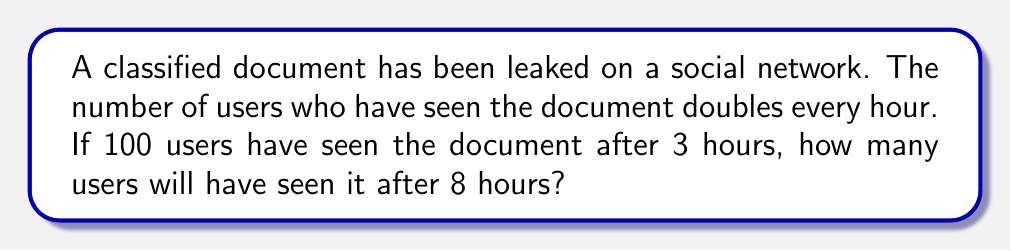Solve this math problem. Let's approach this step-by-step:

1) First, we need to find the initial number of users who saw the document.
   Let $x$ be the initial number of users.

2) After 3 hours, the number of users who have seen the document is 100.
   This can be expressed as: $x \cdot 2^3 = 100$

3) Solve for $x$:
   $x = 100 \div 2^3 = 100 \div 8 = 12.5$

4) So, 12.5 users initially saw the document. Since we're dealing with whole users, we'll round down to 12.

5) Now, to find the number of users after 8 hours, we use the formula:
   $12 \cdot 2^8$

6) Calculate:
   $12 \cdot 2^8 = 12 \cdot 256 = 3,072$

Therefore, after 8 hours, 3,072 users will have seen the classified document.
Answer: 3,072 users 